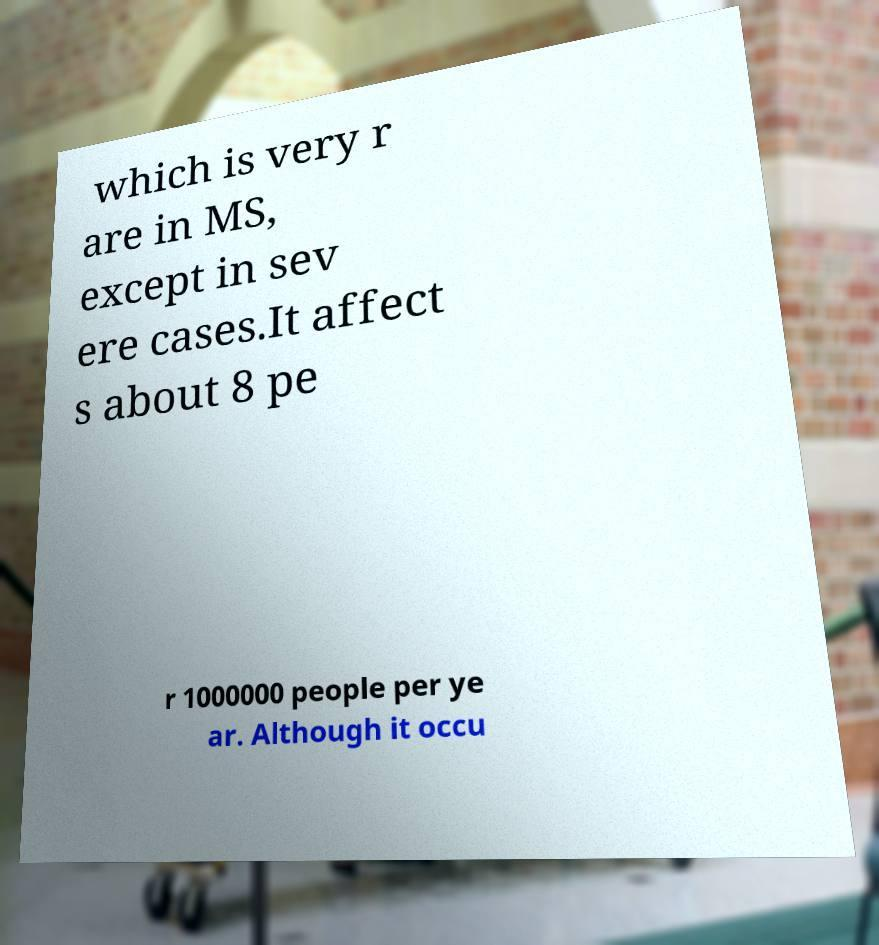Could you extract and type out the text from this image? which is very r are in MS, except in sev ere cases.It affect s about 8 pe r 1000000 people per ye ar. Although it occu 